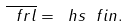<formula> <loc_0><loc_0><loc_500><loc_500>\overline { \ f r l } = \ h s \ f i n .</formula> 